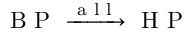Convert formula to latex. <formula><loc_0><loc_0><loc_500><loc_500>B P \xrightarrow { a l l } H P</formula> 